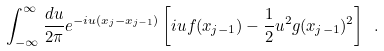Convert formula to latex. <formula><loc_0><loc_0><loc_500><loc_500>\int _ { - \infty } ^ { \infty } \frac { d u } { 2 \pi } e ^ { - i u ( x _ { j } - x _ { j - 1 } ) } \left [ i u f ( x _ { j - 1 } ) - \frac { 1 } { 2 } u ^ { 2 } g ( x _ { j - 1 } ) ^ { 2 } \right ] \ .</formula> 